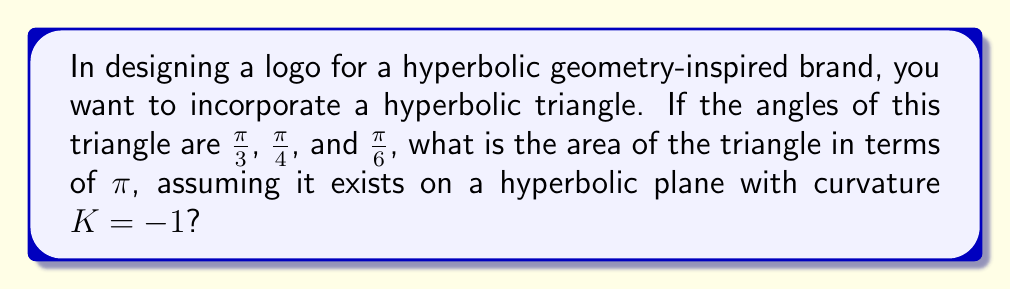Provide a solution to this math problem. To solve this problem, we'll use the Gauss-Bonnet formula for hyperbolic geometry:

1) The Gauss-Bonnet formula for a hyperbolic triangle states:
   $$A = \pi - (\alpha + \beta + \gamma)$$
   where $A$ is the area, and $\alpha$, $\beta$, and $\gamma$ are the angles of the triangle.

2) We're given the angles:
   $\alpha = \frac{\pi}{3}$, $\beta = \frac{\pi}{4}$, and $\gamma = \frac{\pi}{6}$

3) Let's sum these angles:
   $$\frac{\pi}{3} + \frac{\pi}{4} + \frac{\pi}{6} = \frac{4\pi}{12} + \frac{3\pi}{12} + \frac{2\pi}{12} = \frac{9\pi}{12} = \frac{3\pi}{4}$$

4) Now, let's substitute into the Gauss-Bonnet formula:
   $$A = \pi - \frac{3\pi}{4} = \frac{\pi}{4}$$

5) Therefore, the area of the hyperbolic triangle is $\frac{\pi}{4}$.

Note: In Euclidean geometry, the sum of angles in a triangle is always $\pi$, and this triangle would be impossible. In hyperbolic geometry, the sum of angles is always less than $\pi$, allowing for this triangle to exist.
Answer: $\frac{\pi}{4}$ 